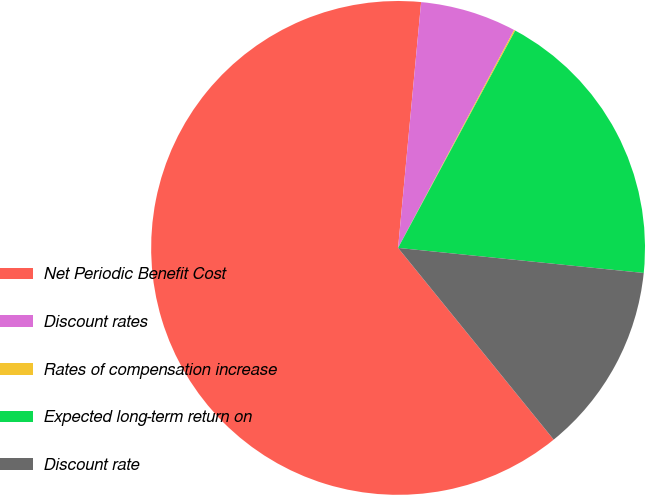Convert chart to OTSL. <chart><loc_0><loc_0><loc_500><loc_500><pie_chart><fcel>Net Periodic Benefit Cost<fcel>Discount rates<fcel>Rates of compensation increase<fcel>Expected long-term return on<fcel>Discount rate<nl><fcel>62.34%<fcel>6.3%<fcel>0.08%<fcel>18.75%<fcel>12.53%<nl></chart> 